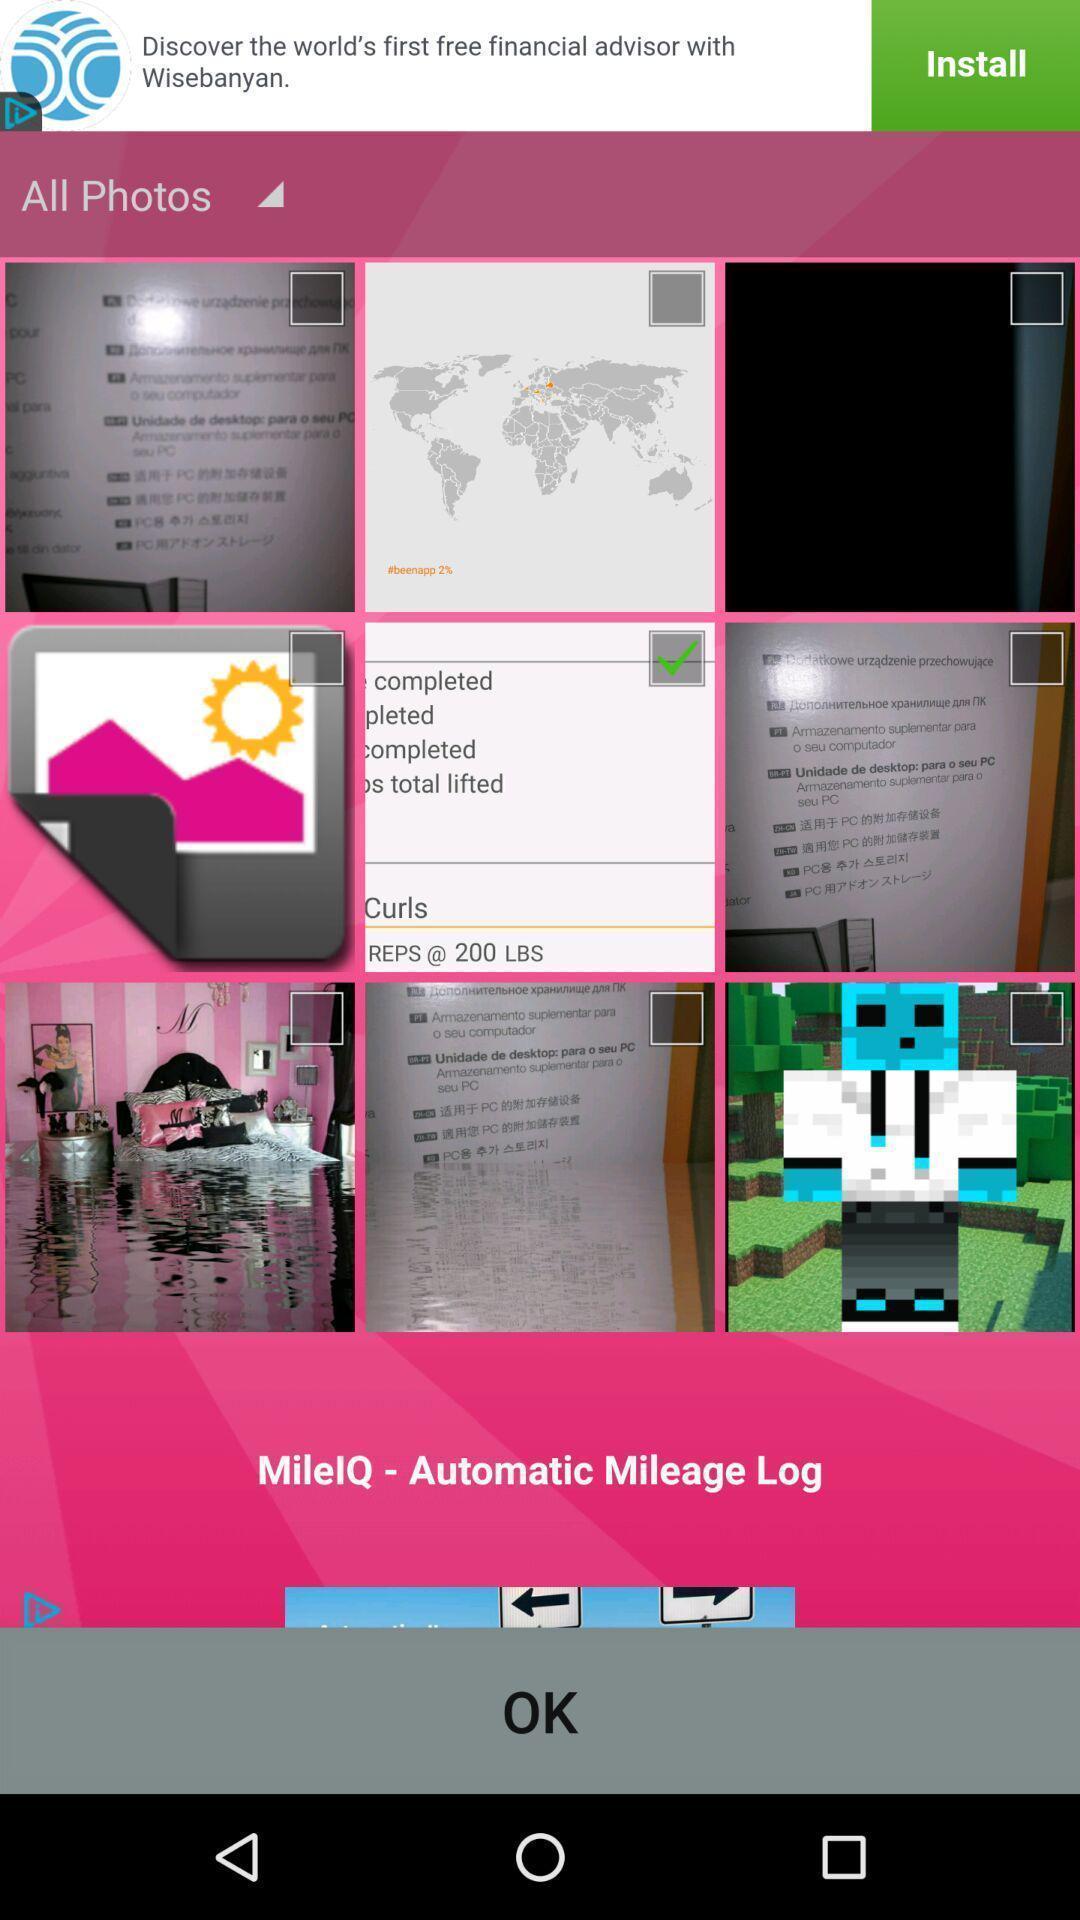Describe the content in this image. Page to select photos in a photo framing app. 